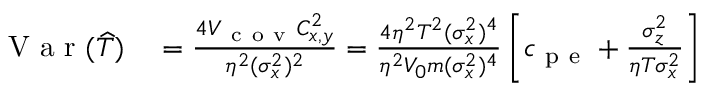<formula> <loc_0><loc_0><loc_500><loc_500>\begin{array} { r l } { V a r ( \widehat { T } ) } & = \frac { 4 V _ { c o v } C _ { x , y } ^ { 2 } } { \eta ^ { 2 } ( \sigma _ { x } ^ { 2 } ) ^ { 2 } } = \frac { 4 \eta ^ { 2 } T ^ { 2 } ( \sigma _ { x } ^ { 2 } ) ^ { 4 } } { \eta ^ { 2 } V _ { 0 } m ( \sigma _ { x } ^ { 2 } ) ^ { 4 } } \left [ c _ { p e } + \frac { \sigma _ { z } ^ { 2 } } { \eta T \sigma _ { x } ^ { 2 } } \right ] } \end{array}</formula> 